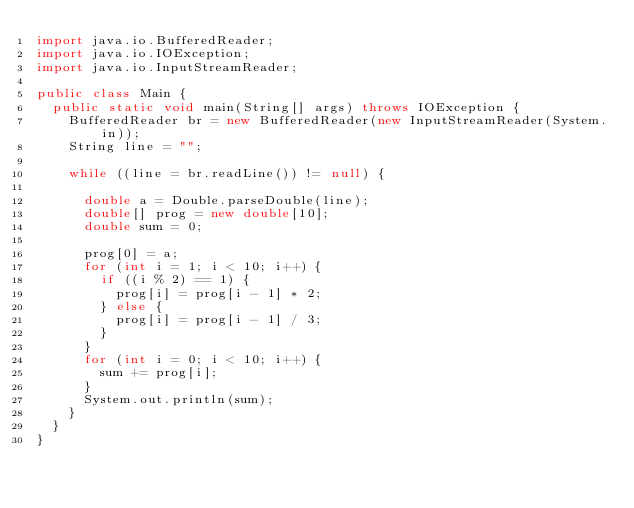Convert code to text. <code><loc_0><loc_0><loc_500><loc_500><_Java_>import java.io.BufferedReader;
import java.io.IOException;
import java.io.InputStreamReader;

public class Main {
	public static void main(String[] args) throws IOException {
		BufferedReader br = new BufferedReader(new InputStreamReader(System.in));
		String line = "";

		while ((line = br.readLine()) != null) {

			double a = Double.parseDouble(line);
			double[] prog = new double[10];
			double sum = 0;

			prog[0] = a;
			for (int i = 1; i < 10; i++) {
				if ((i % 2) == 1) {
					prog[i] = prog[i - 1] * 2;
				} else {
					prog[i] = prog[i - 1] / 3;
				}
			}
			for (int i = 0; i < 10; i++) {
				sum += prog[i];
			}
			System.out.println(sum);
		}
	}
}</code> 